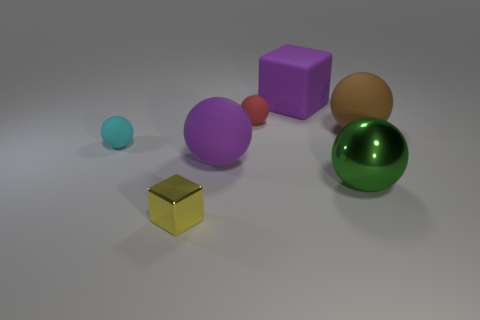Is there any other thing that is the same size as the cyan rubber sphere?
Provide a short and direct response. Yes. The small thing that is made of the same material as the small cyan ball is what color?
Your answer should be compact. Red. There is a cube on the left side of the large purple sphere; is it the same color as the cube to the right of the red sphere?
Provide a short and direct response. No. How many balls are cyan objects or brown objects?
Your answer should be compact. 2. Is the number of large purple matte objects behind the brown rubber ball the same as the number of blue balls?
Provide a succinct answer. No. There is a large thing left of the big purple rubber object behind the matte sphere that is right of the big rubber cube; what is it made of?
Offer a terse response. Rubber. There is a thing that is the same color as the matte cube; what material is it?
Give a very brief answer. Rubber. What number of things are either large things that are left of the large green object or big gray cylinders?
Your answer should be compact. 2. What number of things are shiny things or tiny matte things that are on the left side of the yellow metallic cube?
Your answer should be compact. 3. What number of brown spheres are right of the large metallic sphere right of the thing in front of the big green object?
Provide a succinct answer. 1. 